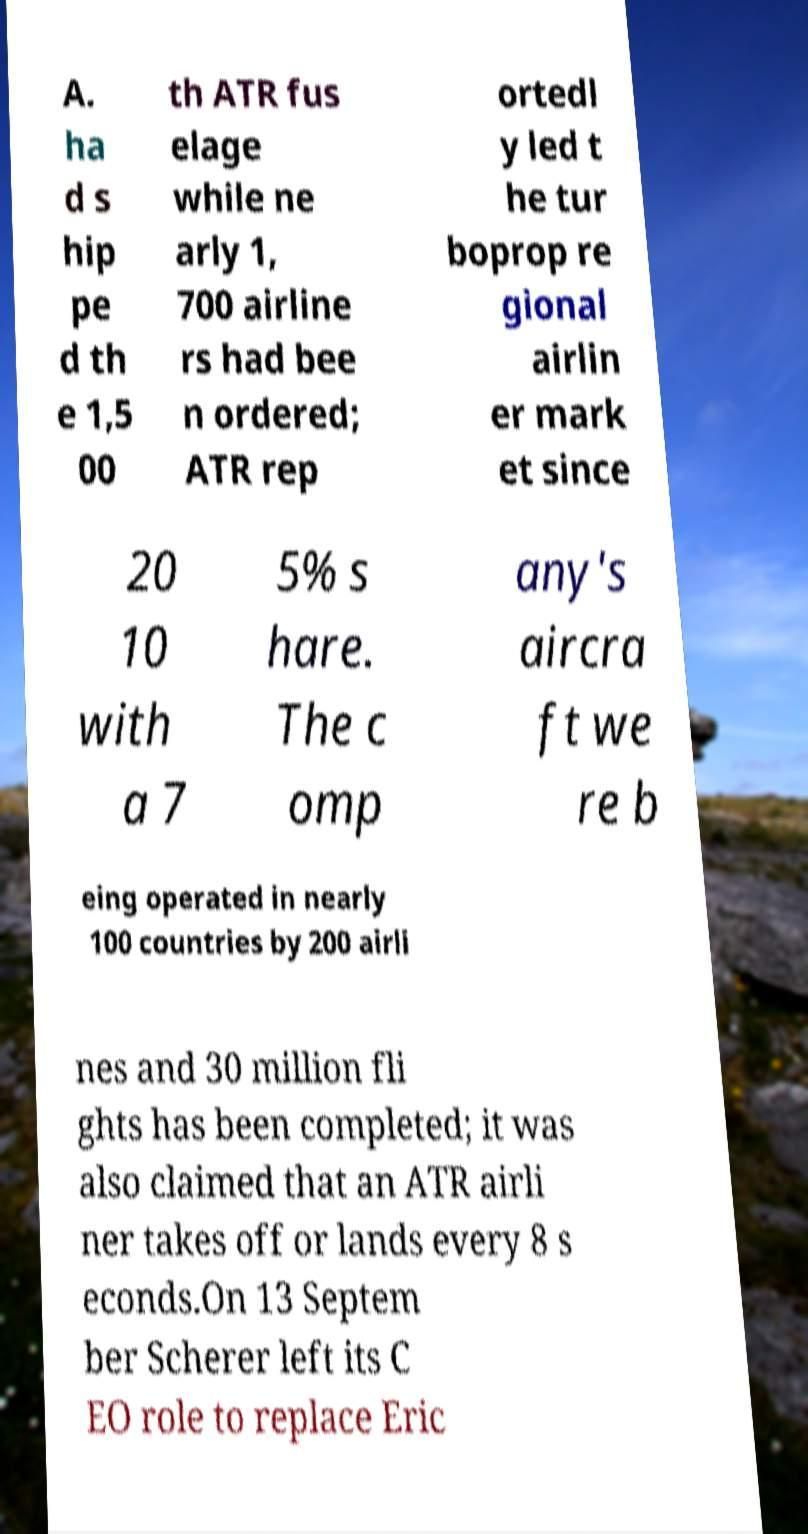I need the written content from this picture converted into text. Can you do that? A. ha d s hip pe d th e 1,5 00 th ATR fus elage while ne arly 1, 700 airline rs had bee n ordered; ATR rep ortedl y led t he tur boprop re gional airlin er mark et since 20 10 with a 7 5% s hare. The c omp any's aircra ft we re b eing operated in nearly 100 countries by 200 airli nes and 30 million fli ghts has been completed; it was also claimed that an ATR airli ner takes off or lands every 8 s econds.On 13 Septem ber Scherer left its C EO role to replace Eric 